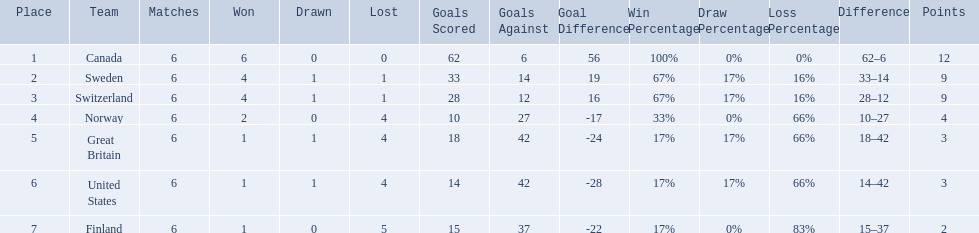What are all the teams? Canada, Sweden, Switzerland, Norway, Great Britain, United States, Finland. What were their points? 12, 9, 9, 4, 3, 3, 2. What about just switzerland and great britain? 9, 3. Now, which of those teams scored higher? Switzerland. 